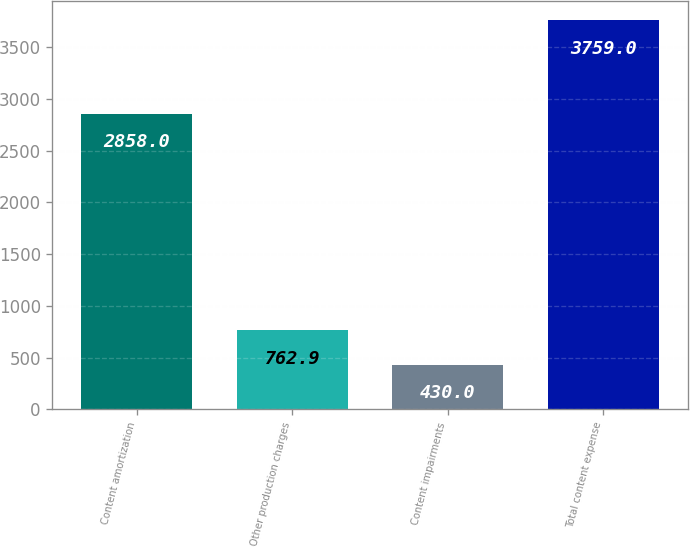Convert chart to OTSL. <chart><loc_0><loc_0><loc_500><loc_500><bar_chart><fcel>Content amortization<fcel>Other production charges<fcel>Content impairments<fcel>Total content expense<nl><fcel>2858<fcel>762.9<fcel>430<fcel>3759<nl></chart> 